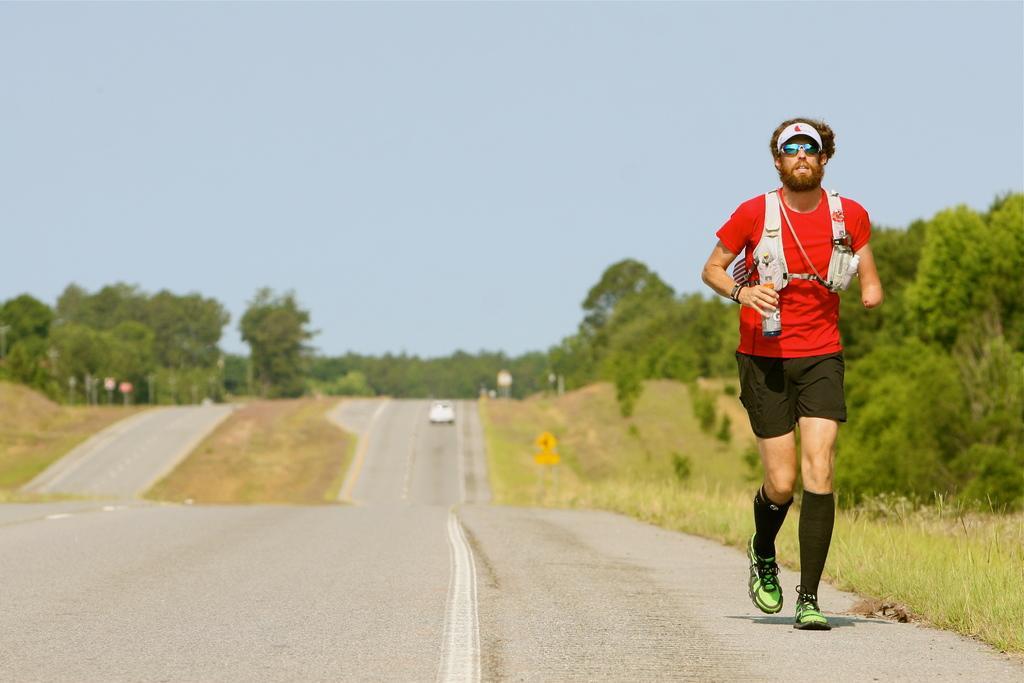Can you describe this image briefly? In the image we can see a man running, wearing clothes, socks, shoes, goggles and a cap, and the man is holding a bottle in his hand. There is a vehicle on the road. Here we can see grass, trees and a pale blue sky. 